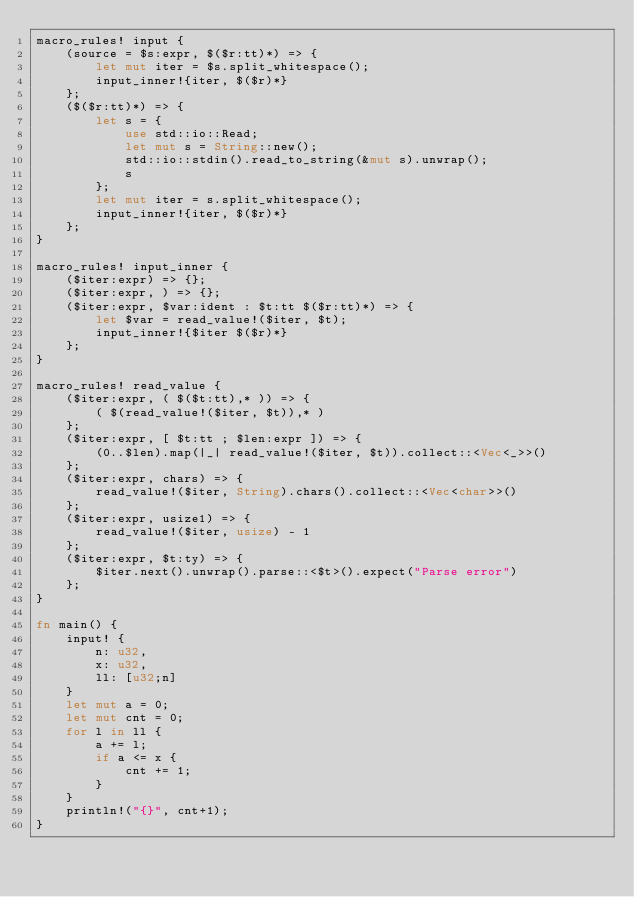Convert code to text. <code><loc_0><loc_0><loc_500><loc_500><_Rust_>macro_rules! input {
    (source = $s:expr, $($r:tt)*) => {
        let mut iter = $s.split_whitespace();
        input_inner!{iter, $($r)*}
    };
    ($($r:tt)*) => {
        let s = {
            use std::io::Read;
            let mut s = String::new();
            std::io::stdin().read_to_string(&mut s).unwrap();
            s
        };
        let mut iter = s.split_whitespace();
        input_inner!{iter, $($r)*}
    };
}

macro_rules! input_inner {
    ($iter:expr) => {};
    ($iter:expr, ) => {};
    ($iter:expr, $var:ident : $t:tt $($r:tt)*) => {
        let $var = read_value!($iter, $t);
        input_inner!{$iter $($r)*}
    };
}

macro_rules! read_value {
    ($iter:expr, ( $($t:tt),* )) => {
        ( $(read_value!($iter, $t)),* )
    };
    ($iter:expr, [ $t:tt ; $len:expr ]) => {
        (0..$len).map(|_| read_value!($iter, $t)).collect::<Vec<_>>()
    };
    ($iter:expr, chars) => {
        read_value!($iter, String).chars().collect::<Vec<char>>()
    };
    ($iter:expr, usize1) => {
        read_value!($iter, usize) - 1
    };
    ($iter:expr, $t:ty) => {
        $iter.next().unwrap().parse::<$t>().expect("Parse error")
    };
}

fn main() {
    input! {
        n: u32,
        x: u32,
        ll: [u32;n]
    }
    let mut a = 0;
    let mut cnt = 0;
    for l in ll {
        a += l;
        if a <= x {
            cnt += 1;
        }
    }
    println!("{}", cnt+1);
}
 </code> 